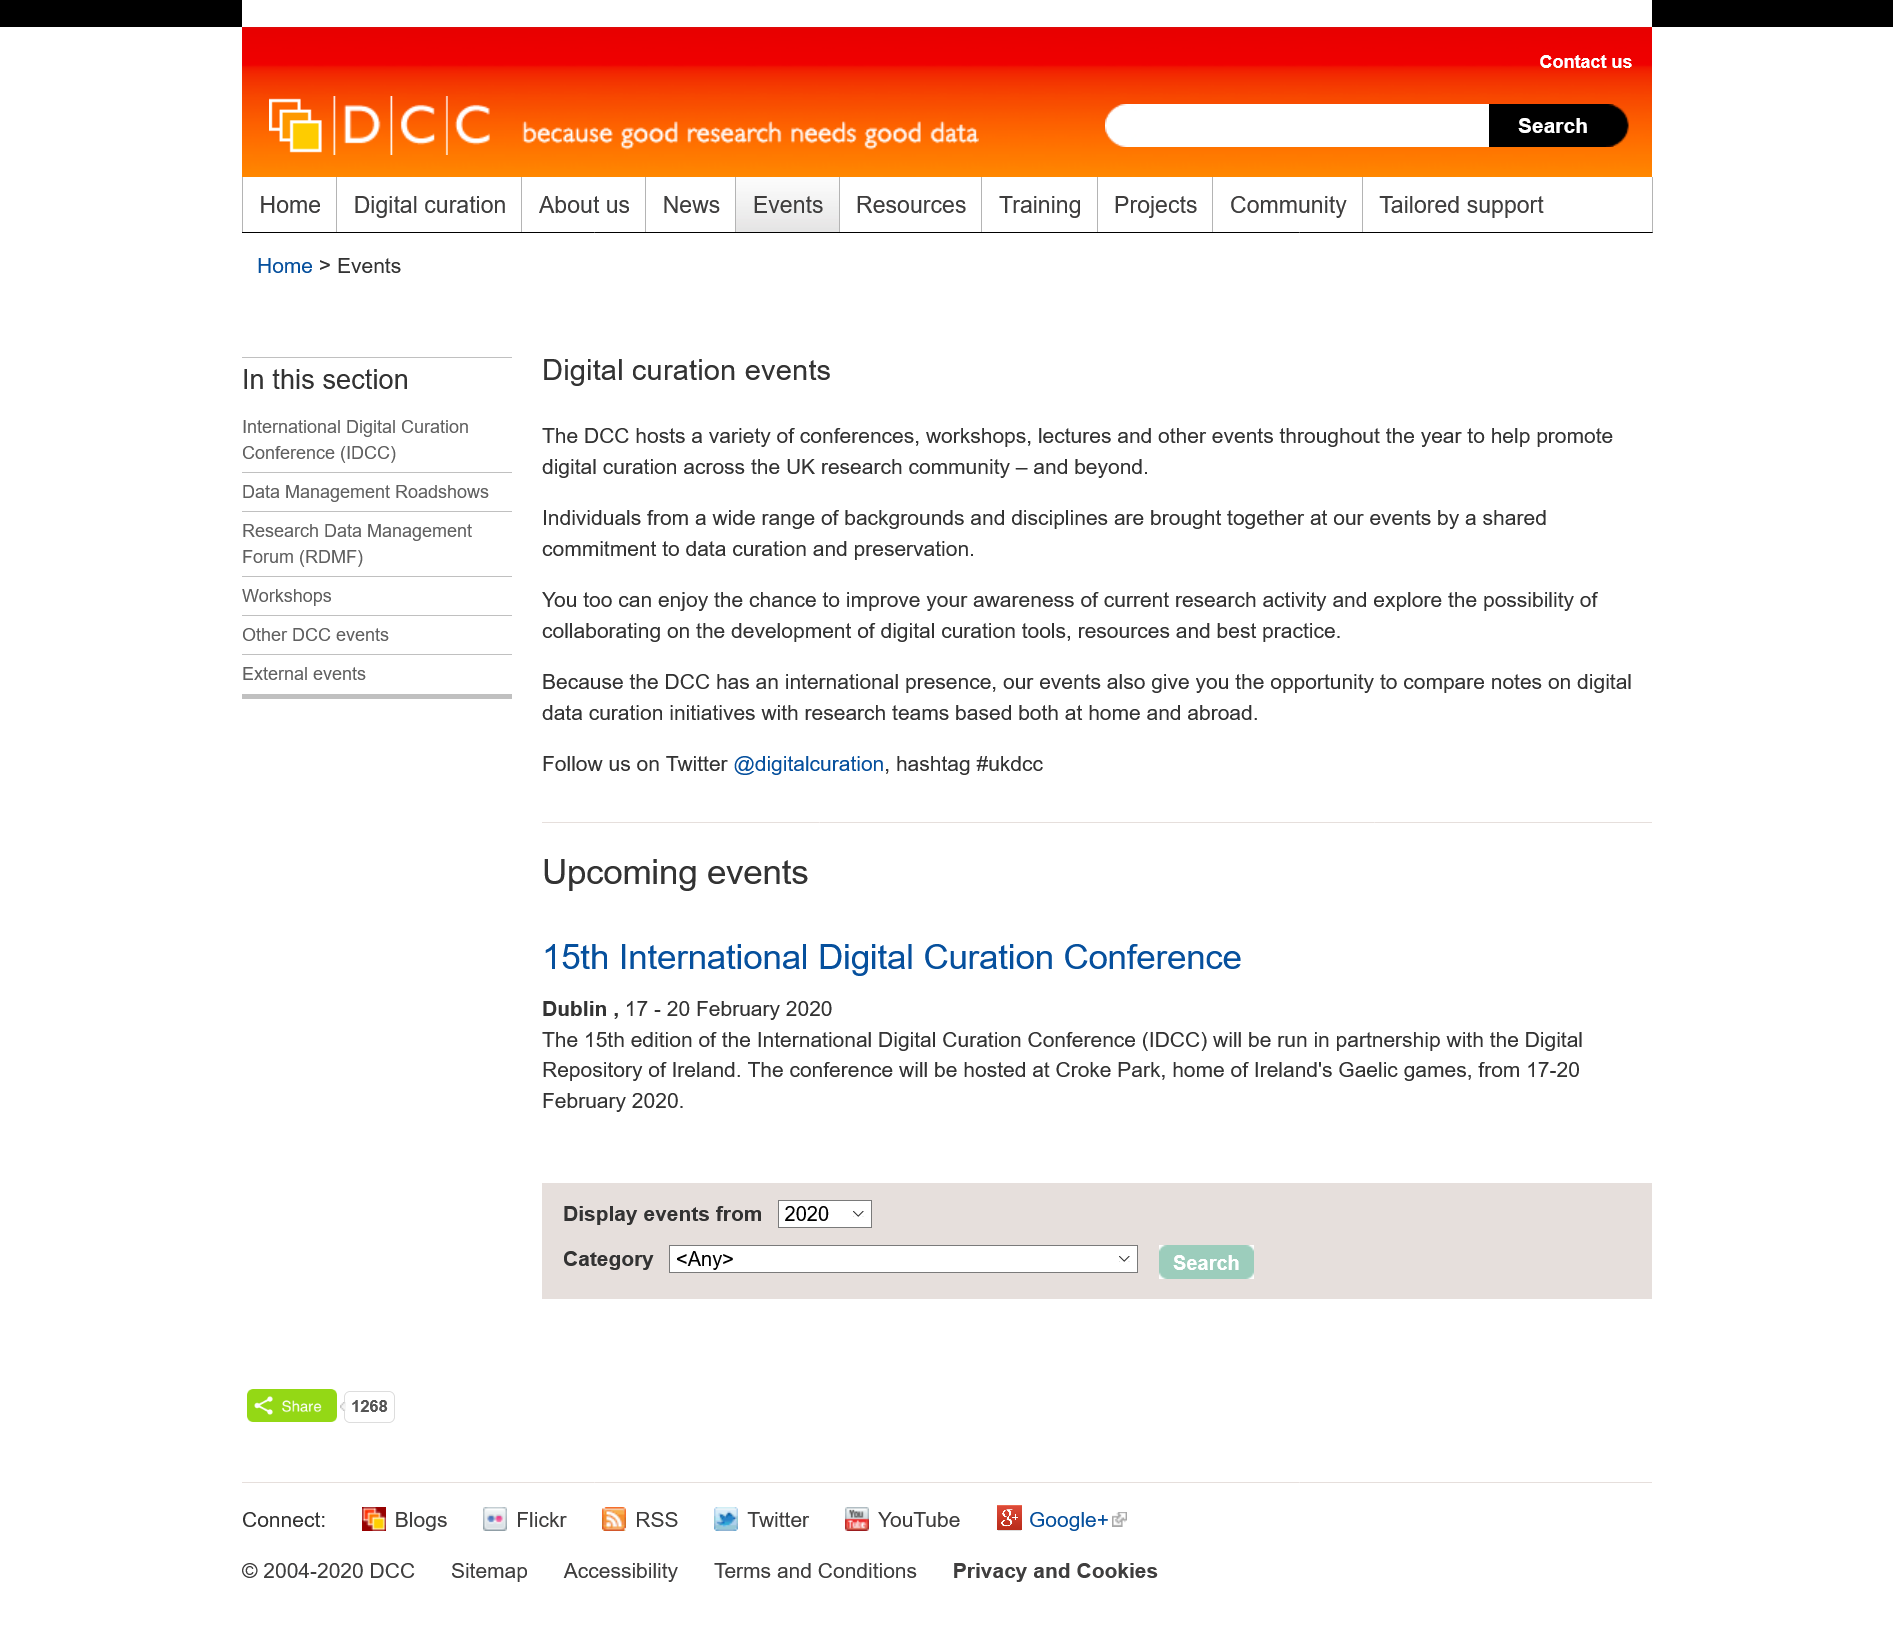List a handful of essential elements in this visual. The hashtag for DCC is #ukdcc. At digital curation events, individuals from diverse backgrounds and fields come together due to a common dedication to data curation and preservation. The Twitter account for DCC is @digitalcuration. 